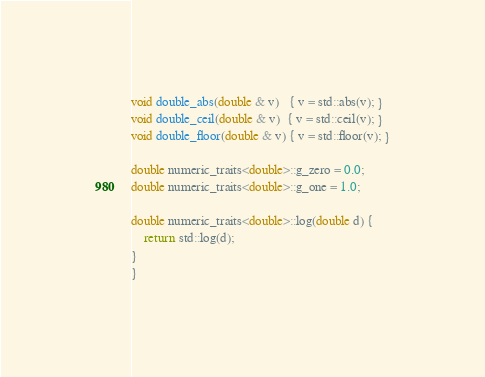Convert code to text. <code><loc_0><loc_0><loc_500><loc_500><_C++_>void double_abs(double & v)   { v = std::abs(v); }
void double_ceil(double & v)  { v = std::ceil(v); }
void double_floor(double & v) { v = std::floor(v); }

double numeric_traits<double>::g_zero = 0.0;
double numeric_traits<double>::g_one = 1.0;

double numeric_traits<double>::log(double d) {
    return std::log(d);
}
}
</code> 